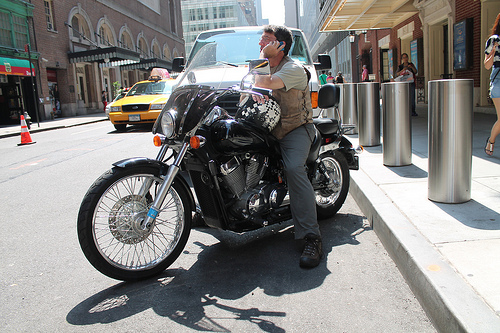Does the woman's hair look blond? It appears that the woman, who isn't fully visible, may have blond hair based on the partial view. 